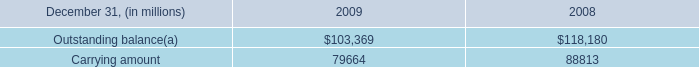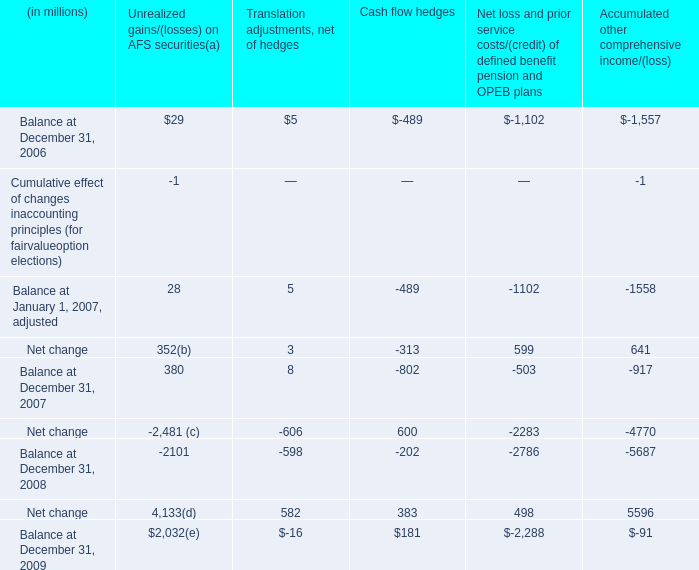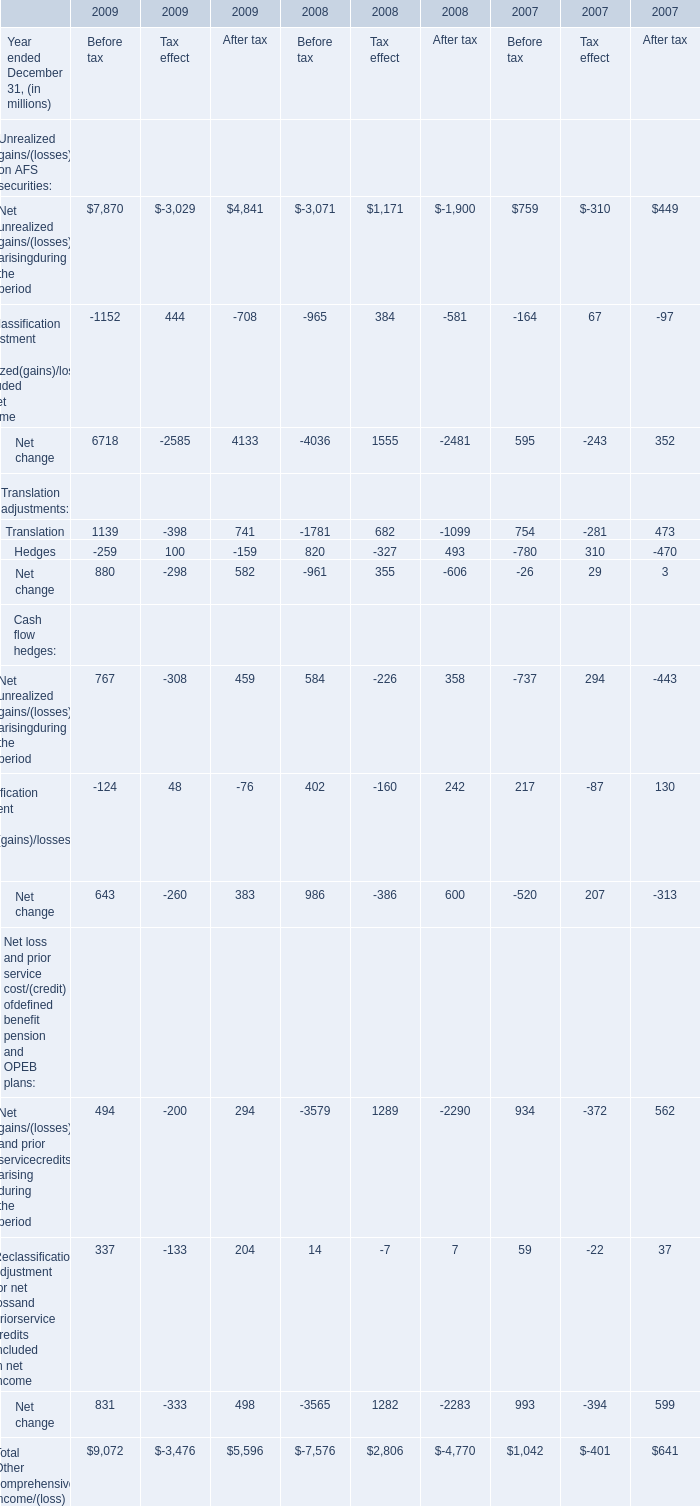for 2009 , what is the average reserve percentage for the prime mortgage and option arm pools of loans?\\n\\n 
Computations: (1.6 / 47.2)
Answer: 0.0339. 